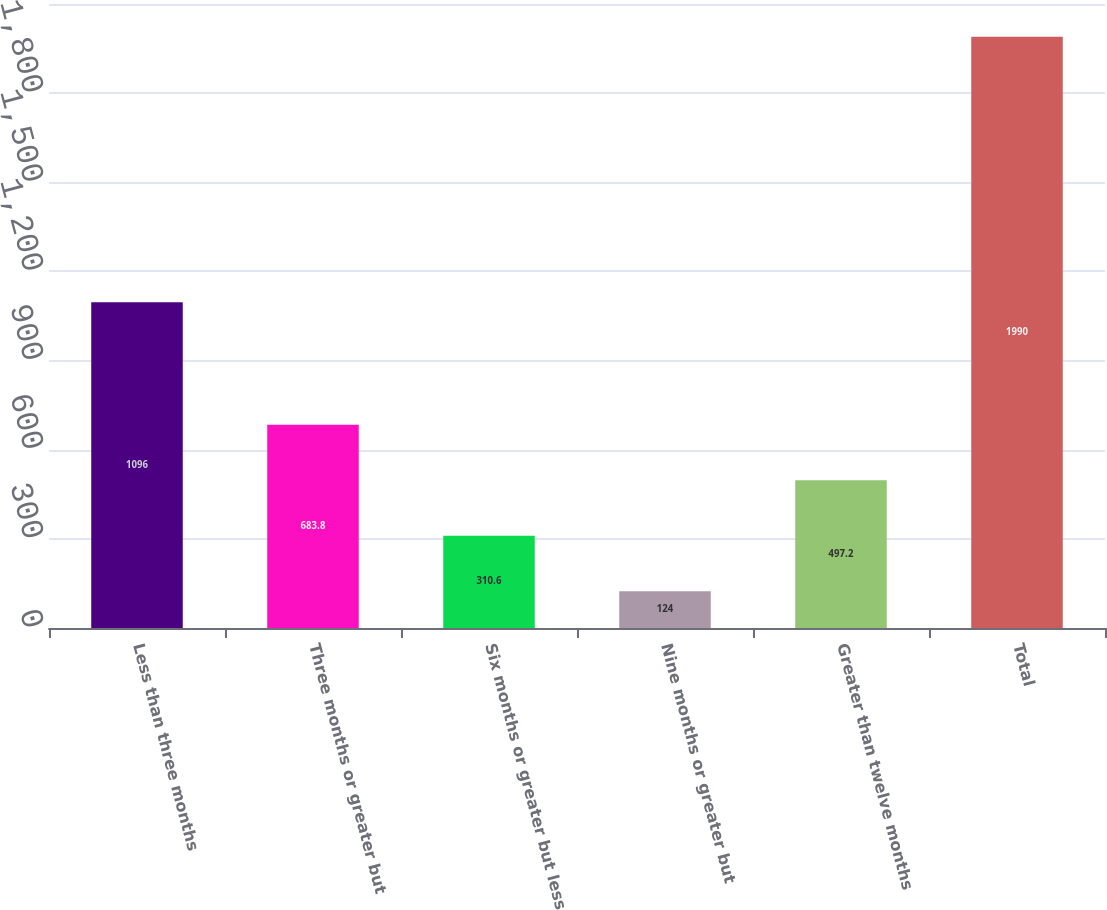Convert chart to OTSL. <chart><loc_0><loc_0><loc_500><loc_500><bar_chart><fcel>Less than three months<fcel>Three months or greater but<fcel>Six months or greater but less<fcel>Nine months or greater but<fcel>Greater than twelve months<fcel>Total<nl><fcel>1096<fcel>683.8<fcel>310.6<fcel>124<fcel>497.2<fcel>1990<nl></chart> 